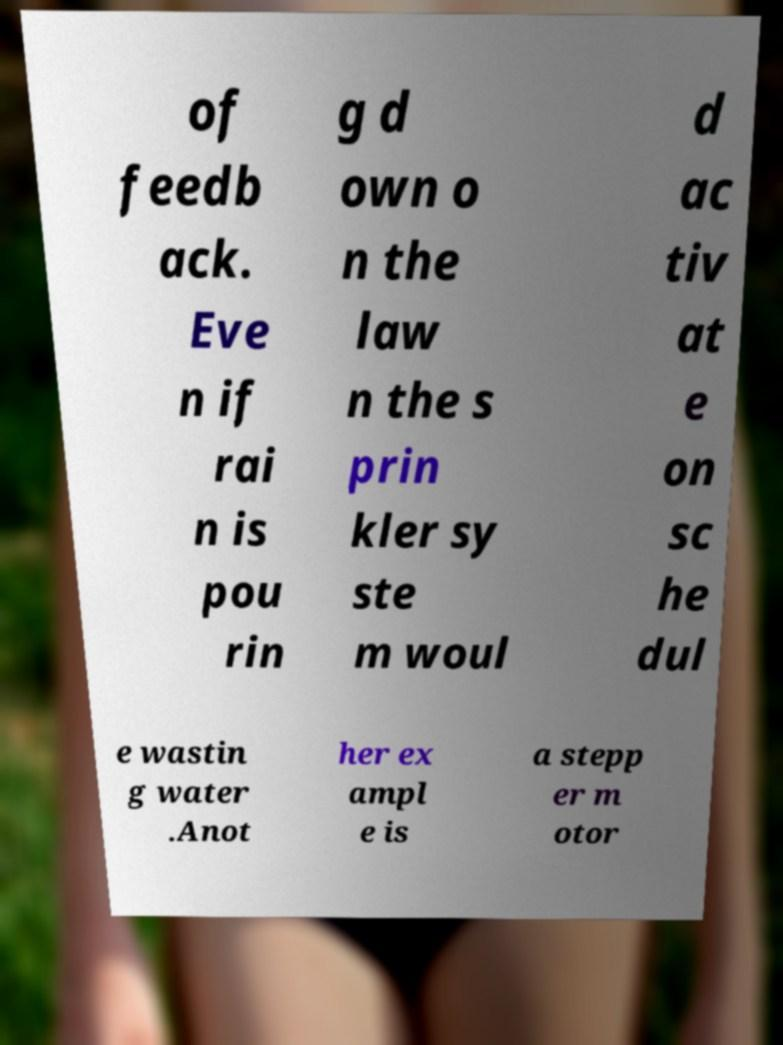Please read and relay the text visible in this image. What does it say? of feedb ack. Eve n if rai n is pou rin g d own o n the law n the s prin kler sy ste m woul d ac tiv at e on sc he dul e wastin g water .Anot her ex ampl e is a stepp er m otor 